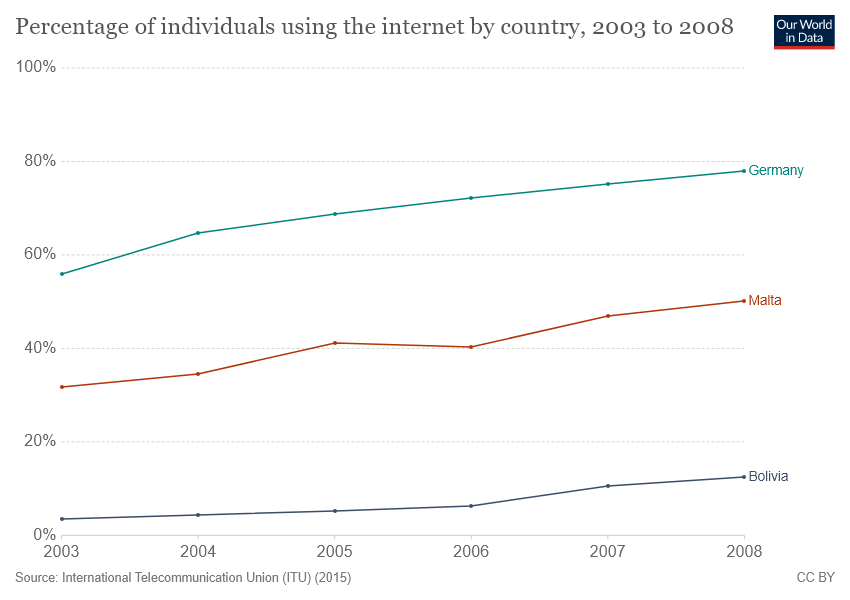Specify some key components in this picture. The peak of all countries was reached in 2008. This image showcases three countries. 